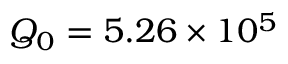<formula> <loc_0><loc_0><loc_500><loc_500>Q _ { 0 } = 5 . 2 6 \times 1 0 ^ { 5 }</formula> 